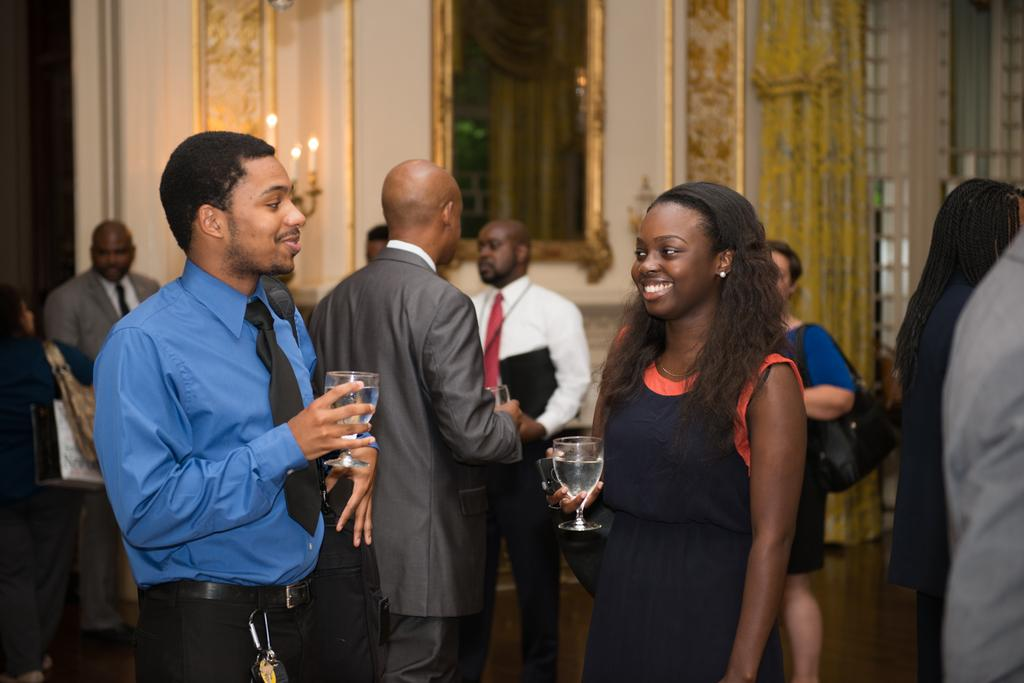What are the two people holding in the image? The two people are holding glasses in the image. Can you describe the other people present in the image? Unfortunately, the provided facts do not give any information about the other people present in the image. How many houses can be seen in the image? There is no information about houses in the provided facts, so we cannot determine how many houses are present in the image. What type of quarter is visible in the image? There is no mention of a quarter in the provided facts, so we cannot determine if a quarter is present in the image. 